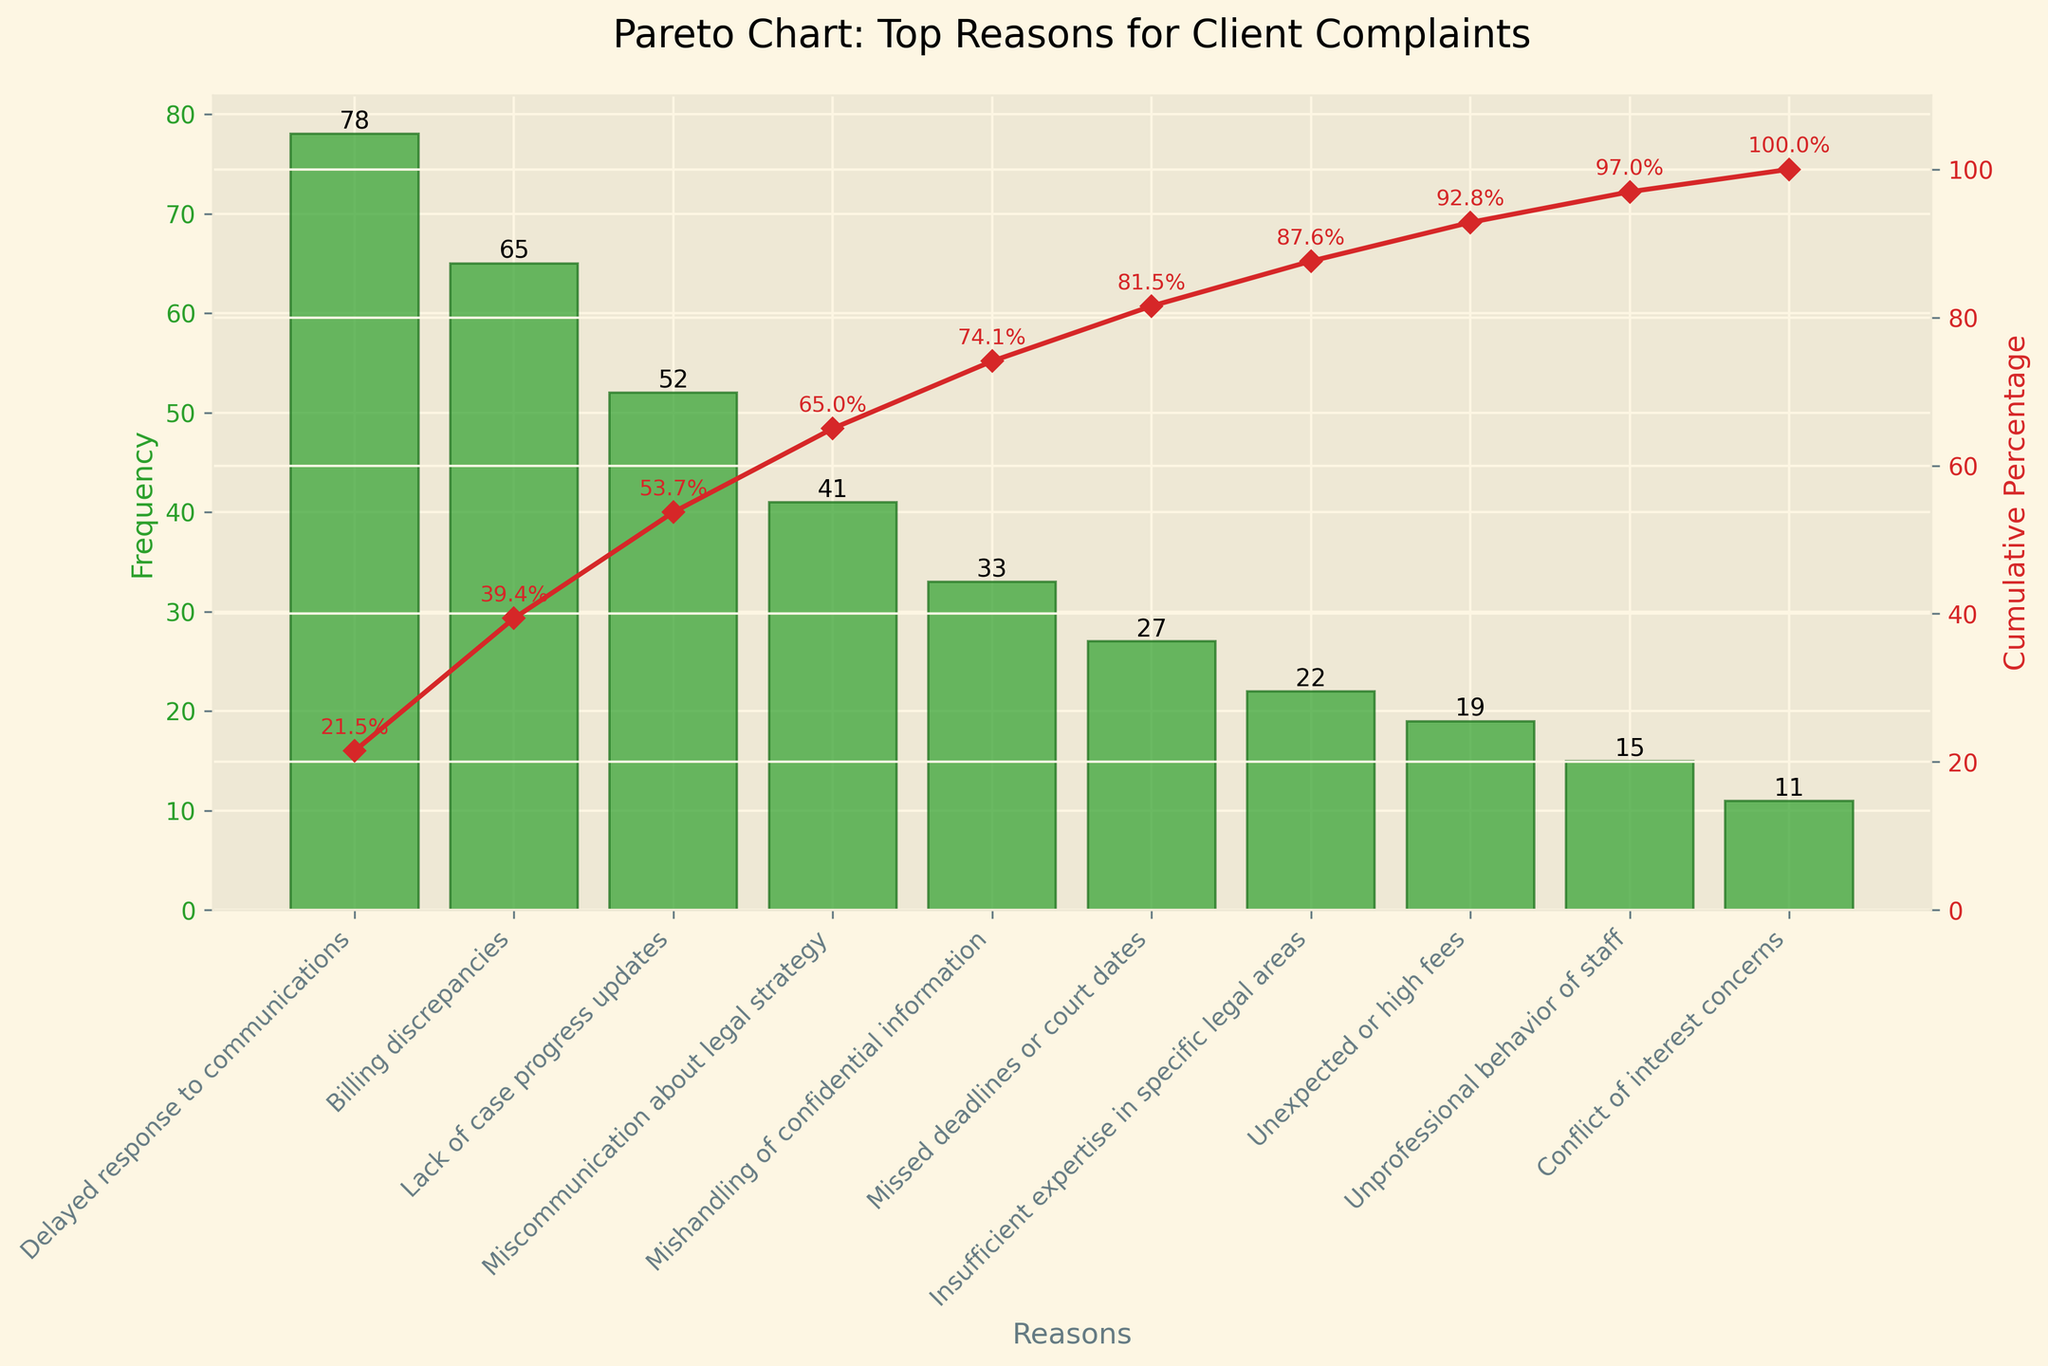What is the title of the chart? The title is located at the top of the chart and provides a general summary of the data being represented. It is clearly displayed.
Answer: Pareto Chart: Top Reasons for Client Complaints How many reasons for client complaints are listed in the chart? The reasons for client complaints are displayed along the x-axis of the chart. By counting the bars, we can determine the total number of reasons.
Answer: 10 What is the reason for the highest frequency of client complaints? The reason with the highest frequency is represented by the tallest bar in the bar plot. It is the first bar from the left, indicating it has the highest occurrence.
Answer: Delayed response to communications What is the cumulative percentage of the top three reasons for client complaints? To find the cumulative percentage, trace the line plot along the y-axis for the first three reasons and note the cumulative percentage value at the third location.
Answer: 60.2% How does the frequency of 'Lack of case progress updates' compare to 'Miscommunication about legal strategy'? Locate these two reasons on the x-axis and compare the height of their respective bars to determine which one has a higher frequency.
Answer: Lack of case progress updates has a higher frequency What cumulative percentage is reached after the first five reasons? The cumulative percentage can be traced from the line plot. Find the value indicated at the fifth position from the left along the x-axis.
Answer: 80% Is the frequency of 'Mishandling of confidential information' greater than 30? Examine the height of the bar corresponding to 'Mishandling of confidential information'. The number on top of the bar provides the exact frequency.
Answer: Yes What percentage of all complaints is accounted for by 'Missed deadlines or court dates'? Divide the frequency of 'Missed deadlines or court dates' by the total number of complaints, then multiply by 100 to find the percentage.
Answer: 8.0% What is the summed frequency of complaints for 'Unexpected or high fees' and 'Missed deadlines or court dates'? Add the frequencies of these two reasons by looking at the heights of their respective bars.
Answer: 46 Is the frequency of 'Unprofessional behavior of staff' less than 'Conflict of interest concerns'? Compare the heights of the bars for these two reasons to determine which one has a lower frequency.
Answer: No 